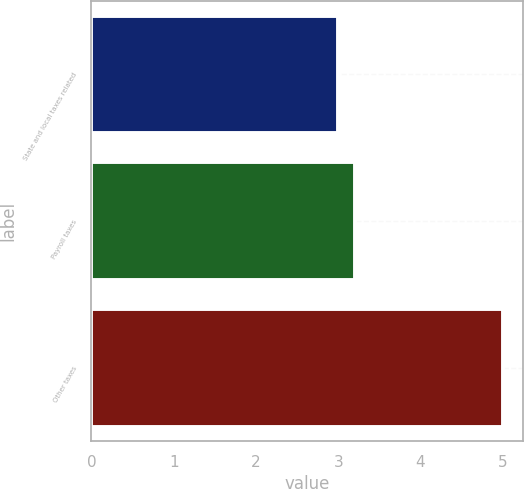Convert chart to OTSL. <chart><loc_0><loc_0><loc_500><loc_500><bar_chart><fcel>State and local taxes related<fcel>Payroll taxes<fcel>Other taxes<nl><fcel>3<fcel>3.2<fcel>5<nl></chart> 